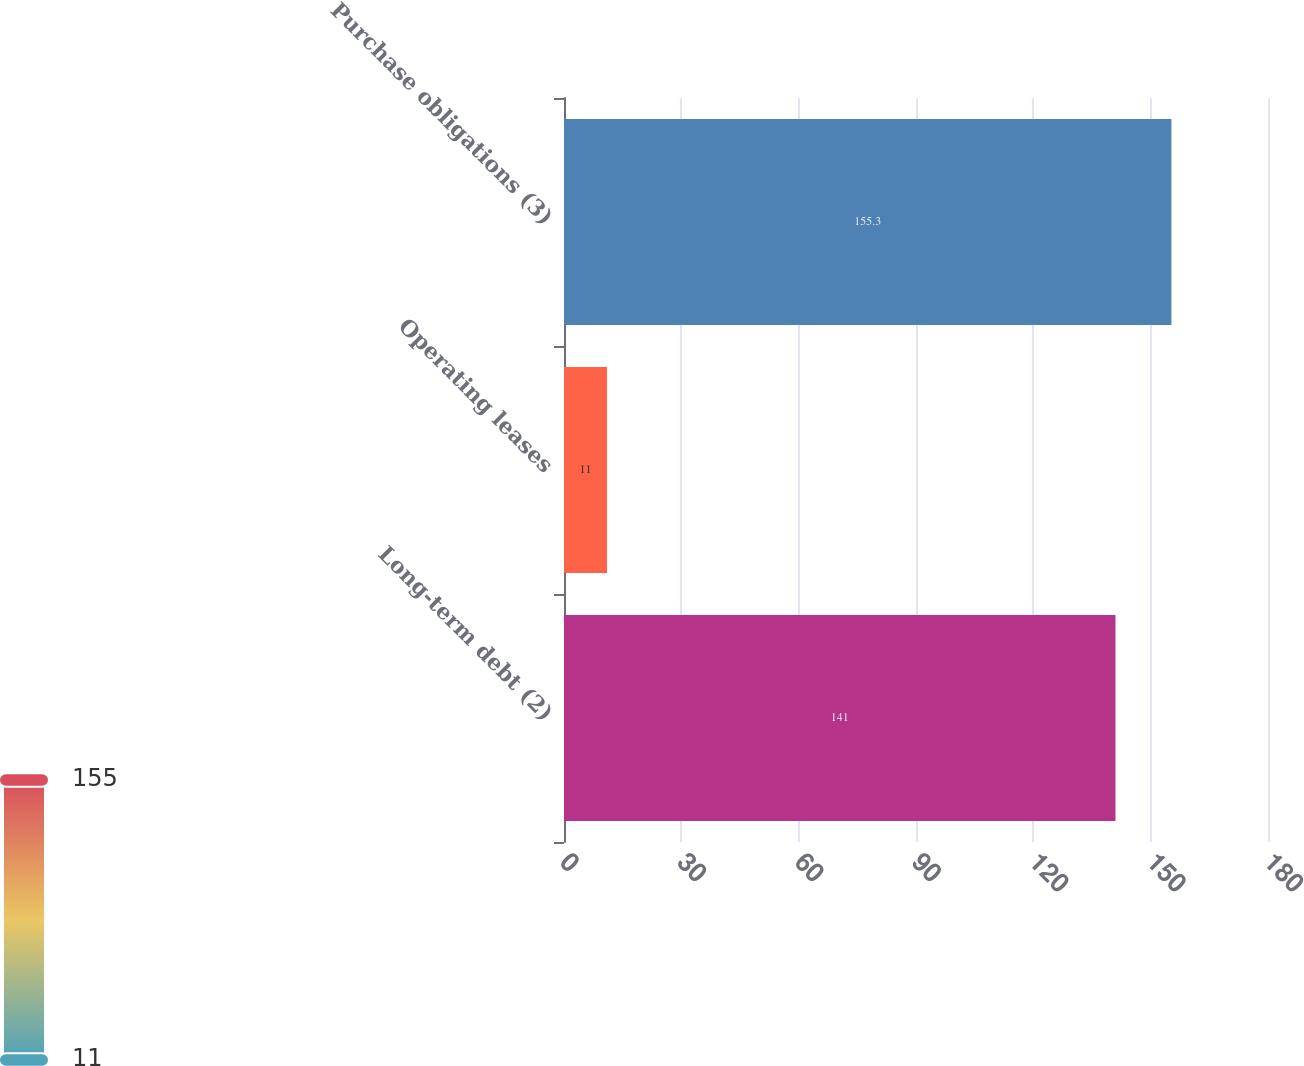<chart> <loc_0><loc_0><loc_500><loc_500><bar_chart><fcel>Long-term debt (2)<fcel>Operating leases<fcel>Purchase obligations (3)<nl><fcel>141<fcel>11<fcel>155.3<nl></chart> 